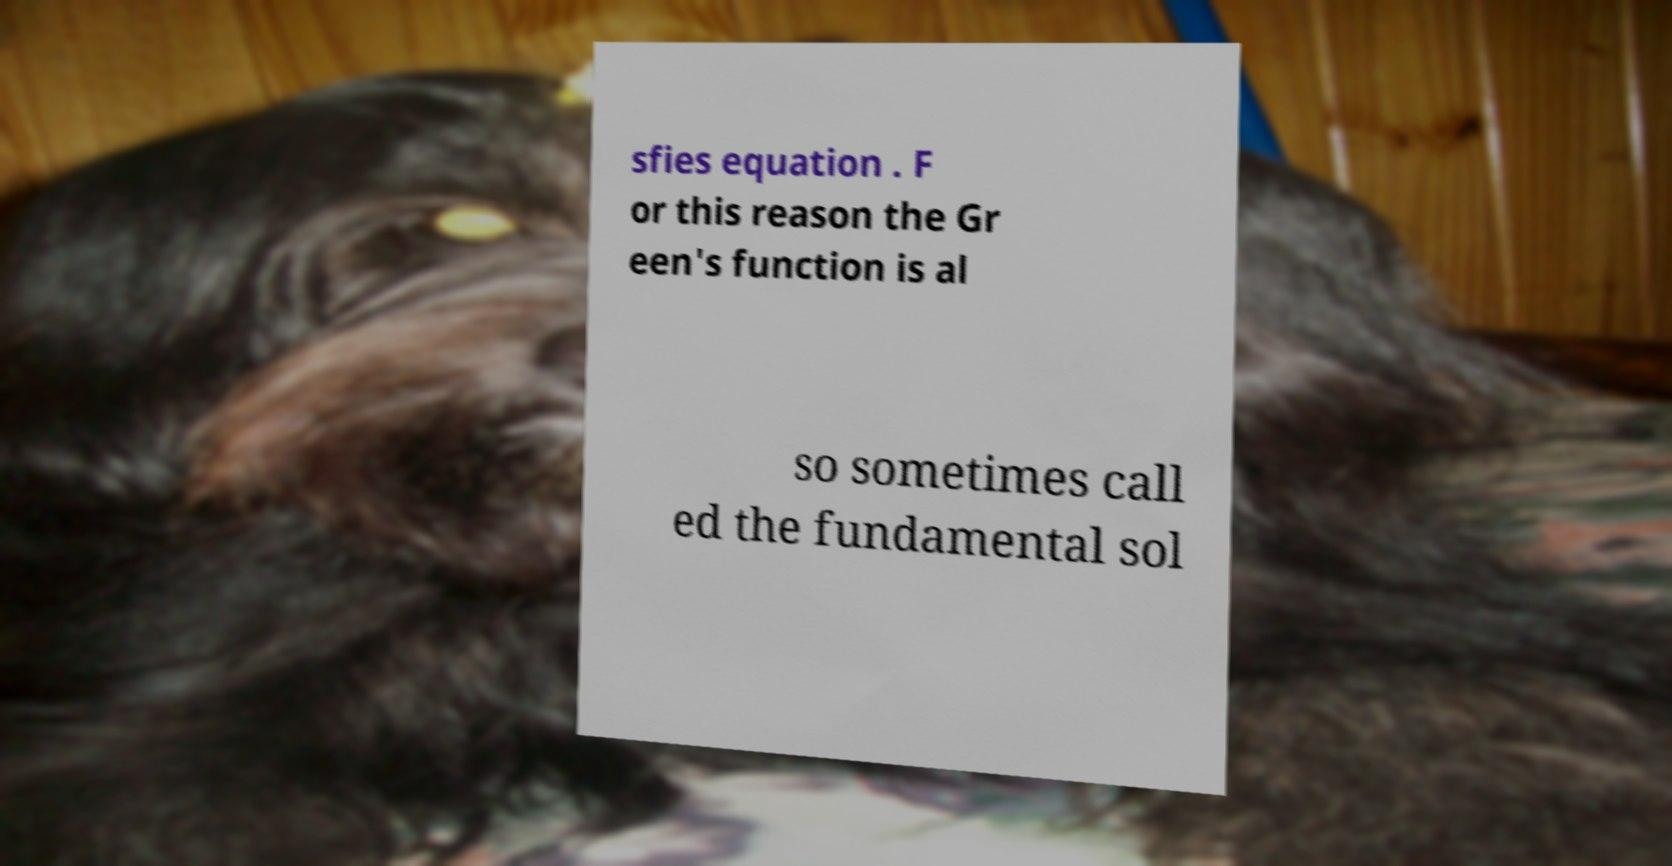Please identify and transcribe the text found in this image. sfies equation . F or this reason the Gr een's function is al so sometimes call ed the fundamental sol 